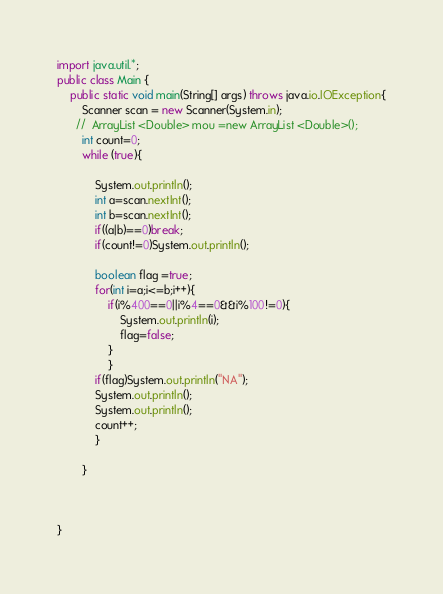<code> <loc_0><loc_0><loc_500><loc_500><_Java_>import java.util.*;
public class Main {
    public static void main(String[] args) throws java.io.IOException{
        Scanner scan = new Scanner(System.in);
      //  ArrayList <Double> mou =new ArrayList <Double>();
        int count=0;
        while (true){
        	
        	System.out.println();
        	int a=scan.nextInt();
        	int b=scan.nextInt();
        	if((a|b)==0)break;
        	if(count!=0)System.out.println();
        	
        	boolean flag =true;
        	for(int i=a;i<=b;i++){
        		if(i%400==0||i%4==0&&i%100!=0){
        			System.out.println(i);
        			flag=false;
        		}
        		}
        	if(flag)System.out.println("NA");
        	System.out.println();
        	System.out.println();
        	count++;
        	}
     
        }
      


}</code> 